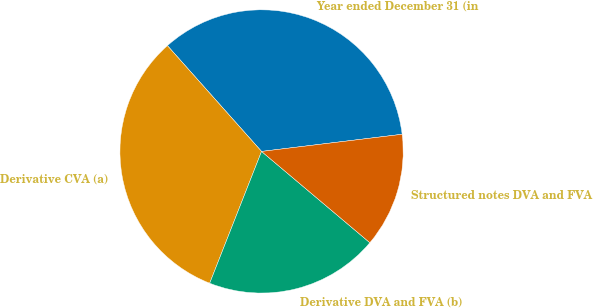<chart> <loc_0><loc_0><loc_500><loc_500><pie_chart><fcel>Year ended December 31 (in<fcel>Derivative CVA (a)<fcel>Derivative DVA and FVA (b)<fcel>Structured notes DVA and FVA<nl><fcel>34.64%<fcel>32.46%<fcel>19.82%<fcel>13.08%<nl></chart> 